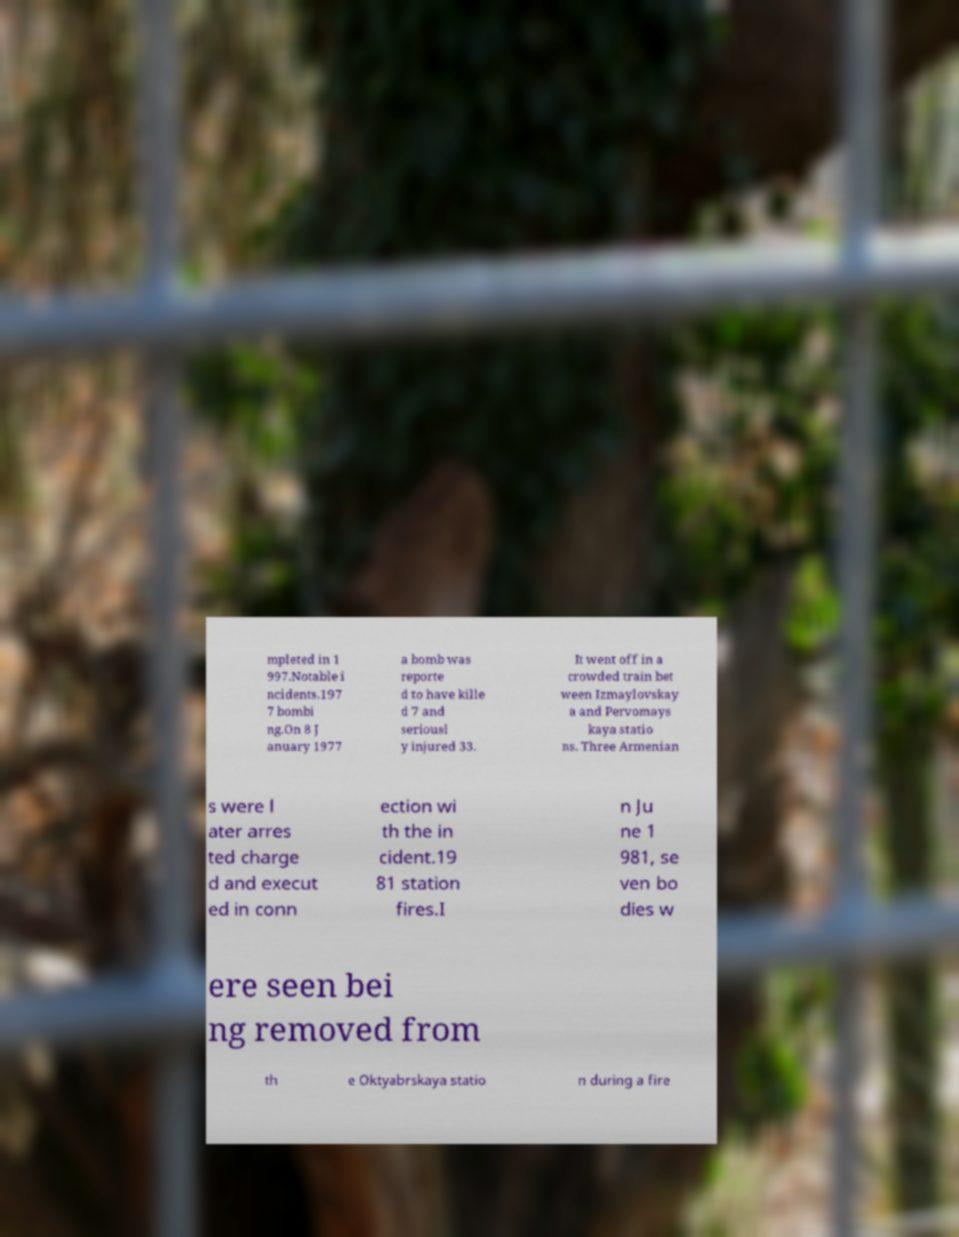Could you extract and type out the text from this image? mpleted in 1 997.Notable i ncidents.197 7 bombi ng.On 8 J anuary 1977 a bomb was reporte d to have kille d 7 and seriousl y injured 33. It went off in a crowded train bet ween Izmaylovskay a and Pervomays kaya statio ns. Three Armenian s were l ater arres ted charge d and execut ed in conn ection wi th the in cident.19 81 station fires.I n Ju ne 1 981, se ven bo dies w ere seen bei ng removed from th e Oktyabrskaya statio n during a fire 